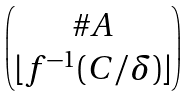<formula> <loc_0><loc_0><loc_500><loc_500>\begin{pmatrix} \# A \\ \lfloor f ^ { - 1 } ( C / \delta ) \rfloor \end{pmatrix}</formula> 